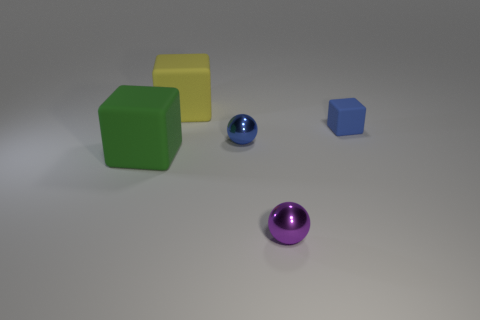Subtract all large yellow rubber blocks. How many blocks are left? 2 Add 5 green metallic cylinders. How many objects exist? 10 Subtract all purple spheres. How many spheres are left? 1 Subtract 2 balls. How many balls are left? 0 Subtract all red blocks. Subtract all cyan balls. How many blocks are left? 3 Subtract all purple cylinders. How many yellow cubes are left? 1 Subtract all green cubes. Subtract all balls. How many objects are left? 2 Add 4 blue metal balls. How many blue metal balls are left? 5 Add 1 small purple shiny spheres. How many small purple shiny spheres exist? 2 Subtract 0 purple cubes. How many objects are left? 5 